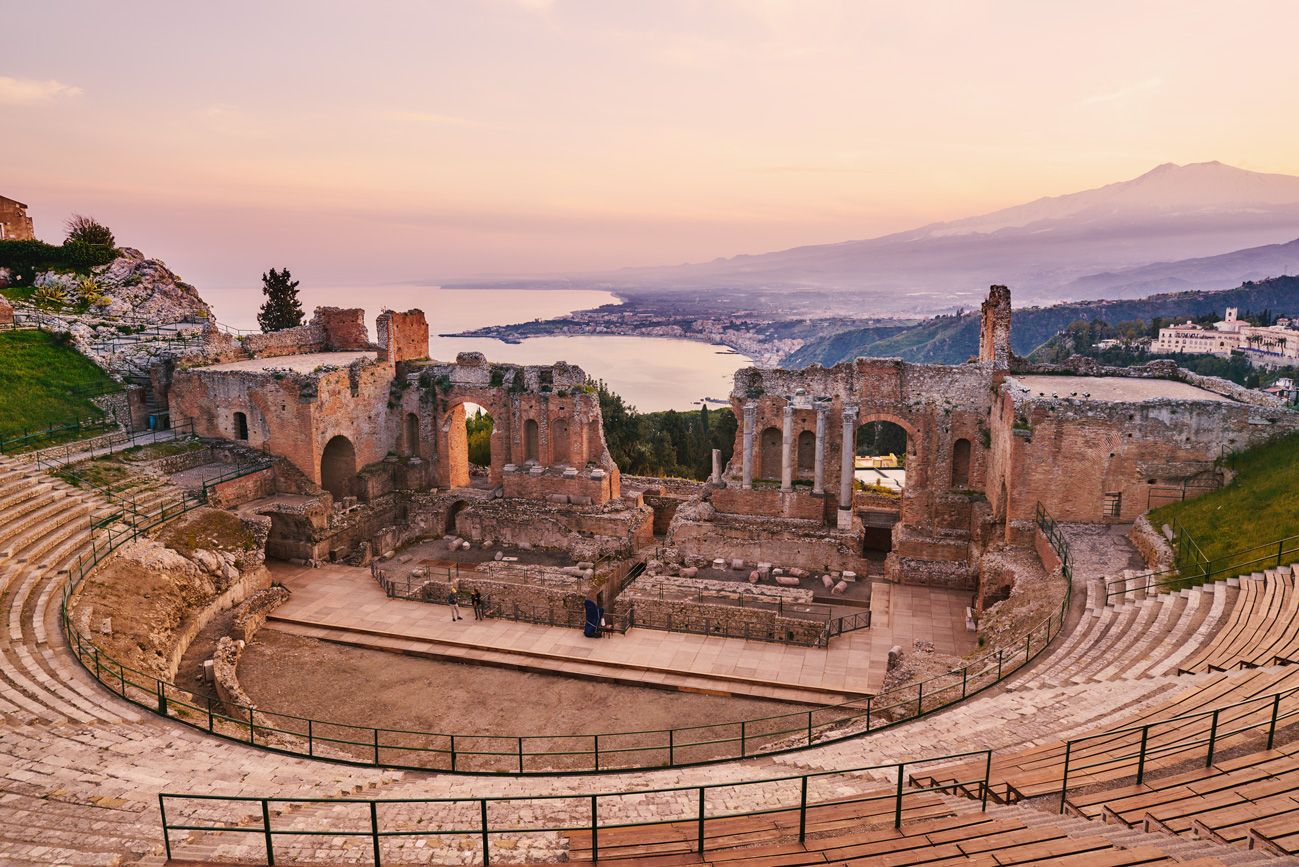How has this site's function changed over time? Originally built for hosting dramatic performances and musical events in ancient Greece, the Taormina Theater underwent several modifications in Roman times, including adjustments for gladiatorial games. Today, it transcends its ancient role to serve as a multifunctional venue for international music concerts, operas, and theatrical performances, making it a living symbol of cultural adaptation and continuity. 